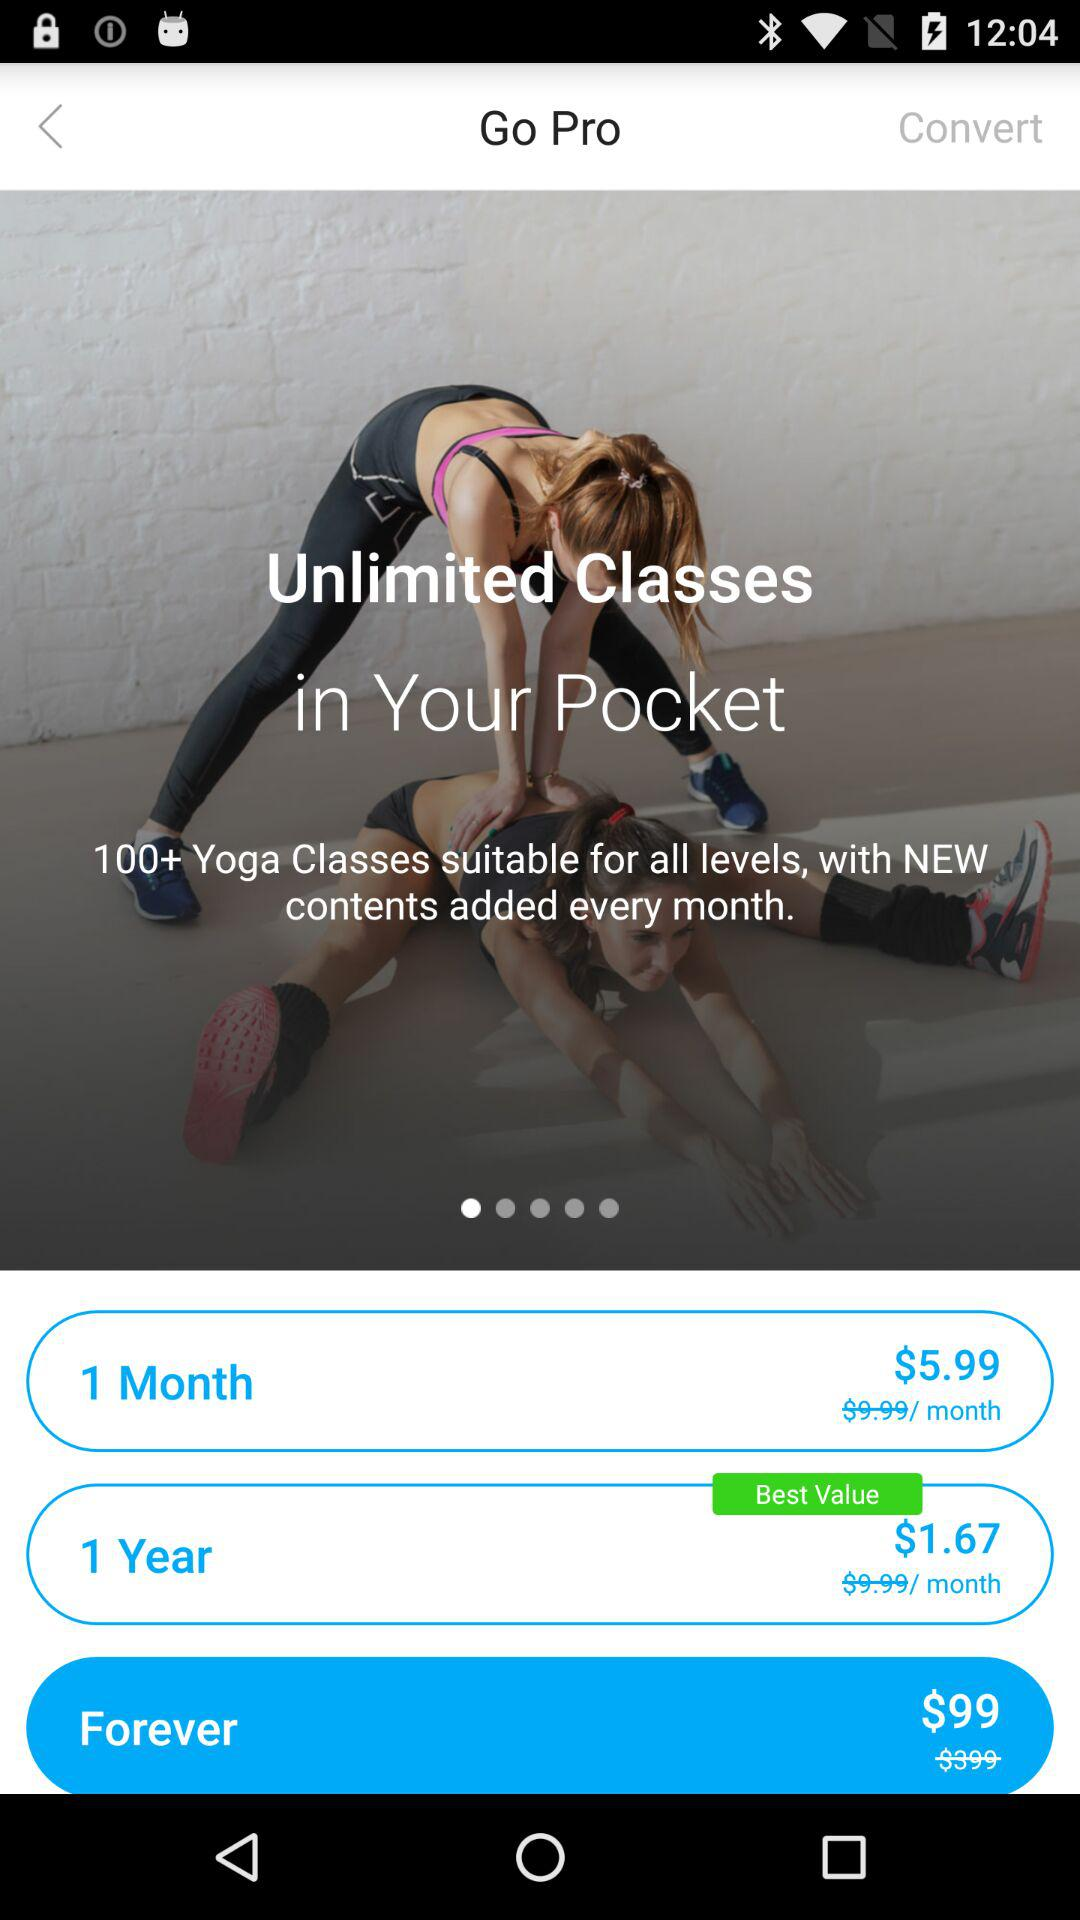Which plan is the most expensive?
Answer the question using a single word or phrase. Forever 